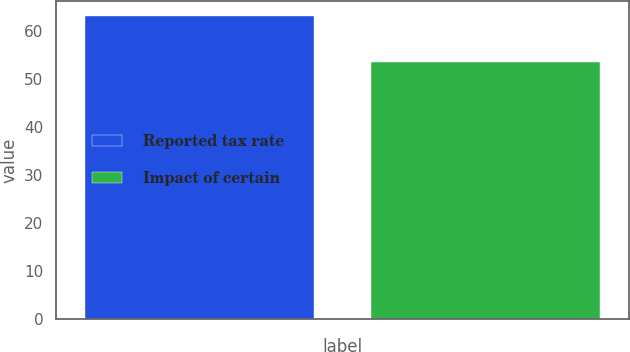Convert chart to OTSL. <chart><loc_0><loc_0><loc_500><loc_500><bar_chart><fcel>Reported tax rate<fcel>Impact of certain<nl><fcel>63.2<fcel>53.5<nl></chart> 